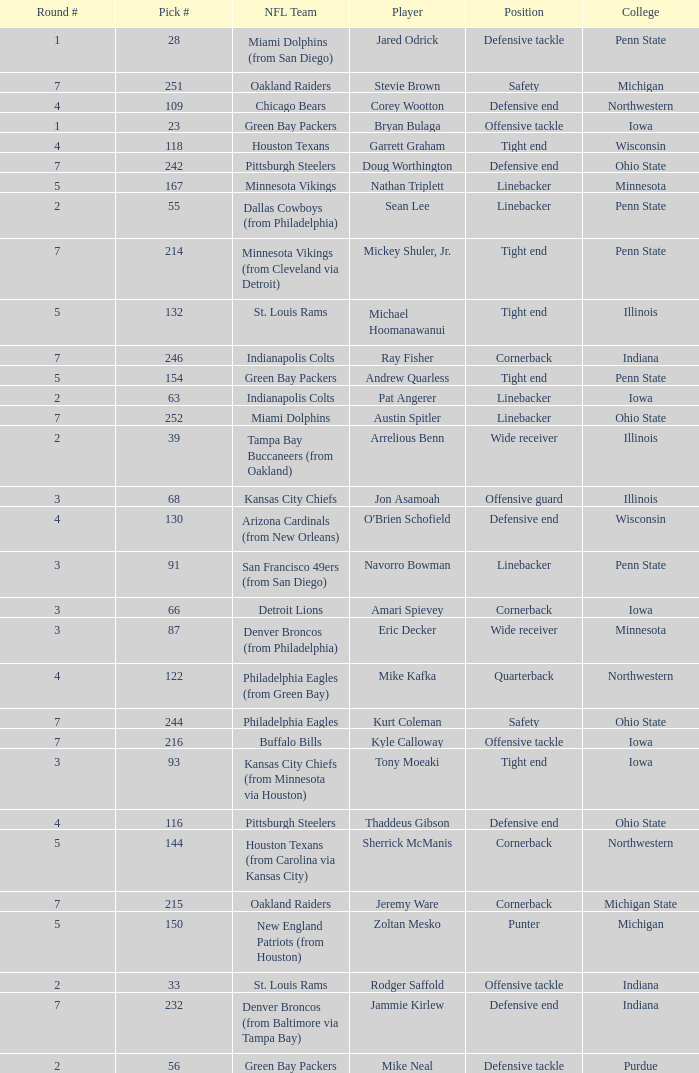What was Sherrick McManis's earliest round? 5.0. 